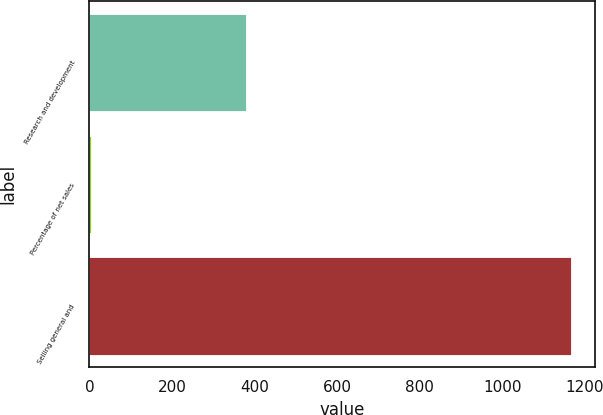<chart> <loc_0><loc_0><loc_500><loc_500><bar_chart><fcel>Research and development<fcel>Percentage of net sales<fcel>Selling general and<nl><fcel>380<fcel>5<fcel>1166<nl></chart> 